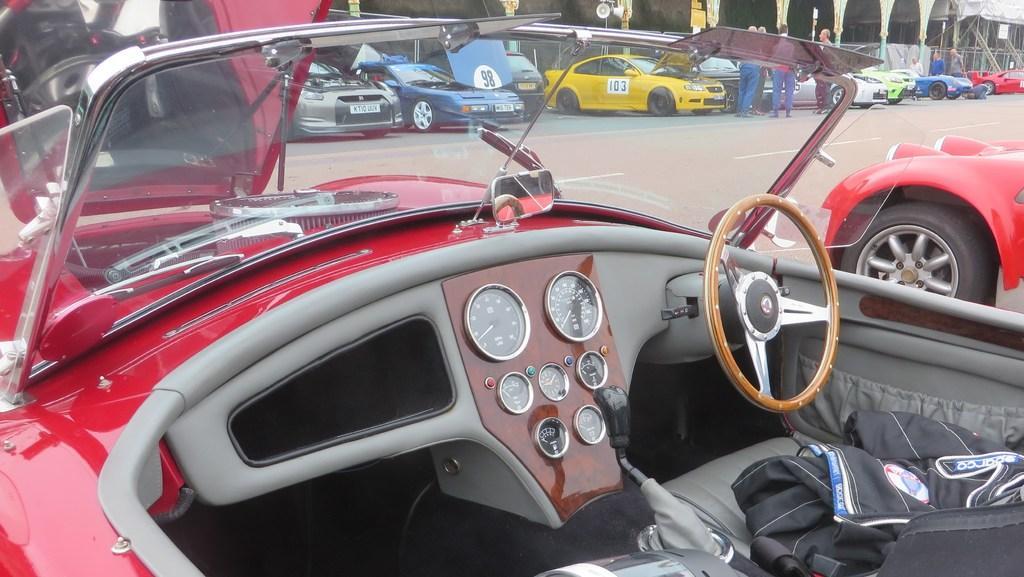In one or two sentences, can you explain what this image depicts? In this image we can see vehicles and persons on the road. 